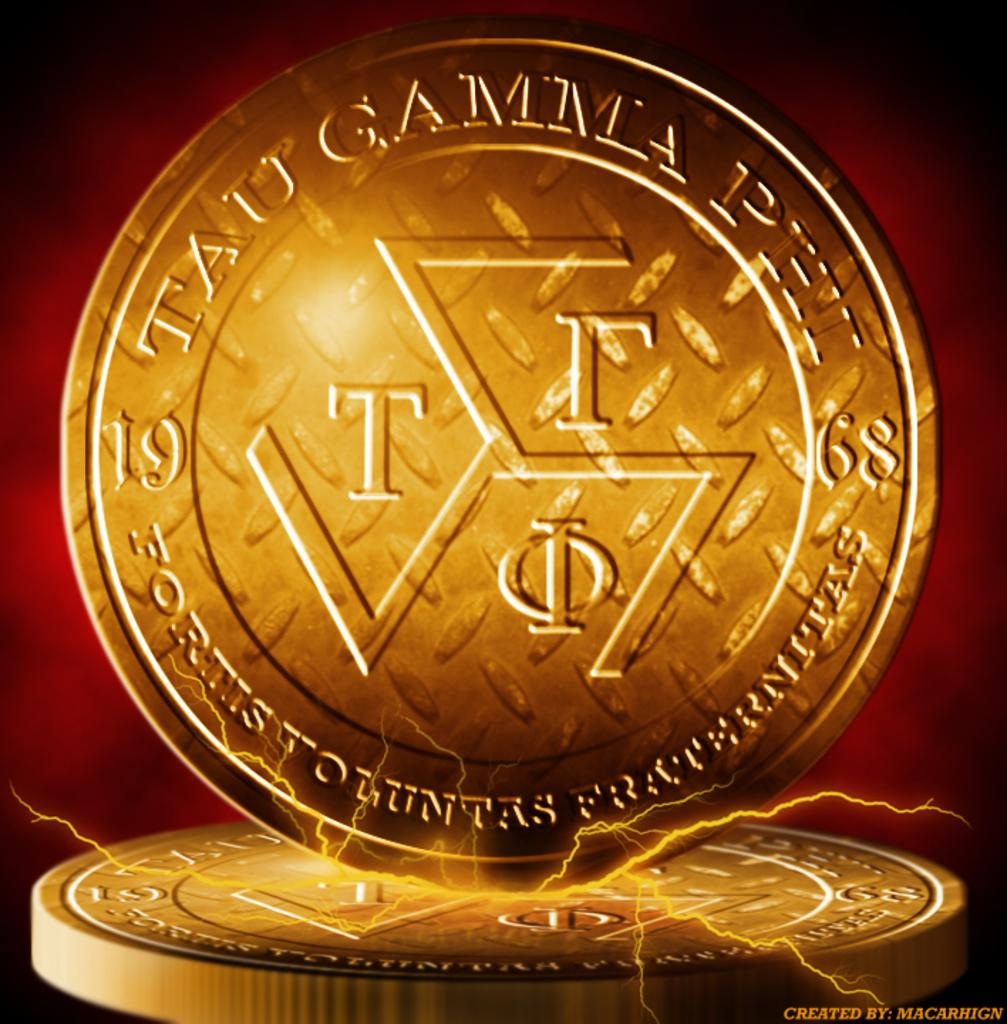<image>
Give a short and clear explanation of the subsequent image. A gold coin with the inscription Tau Gamma Phi 1968 